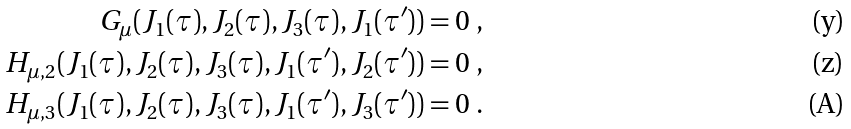<formula> <loc_0><loc_0><loc_500><loc_500>G _ { \mu } ( J _ { 1 } ( \tau ) , J _ { 2 } ( \tau ) , J _ { 3 } ( \tau ) , J _ { 1 } ( \tau ^ { \prime } ) ) = 0 \ , \\ H _ { \mu , 2 } ( J _ { 1 } ( \tau ) , J _ { 2 } ( \tau ) , J _ { 3 } ( \tau ) , J _ { 1 } ( \tau ^ { \prime } ) , J _ { 2 } ( \tau ^ { \prime } ) ) = 0 \ , \\ H _ { \mu , 3 } ( J _ { 1 } ( \tau ) , J _ { 2 } ( \tau ) , J _ { 3 } ( \tau ) , J _ { 1 } ( \tau ^ { \prime } ) , J _ { 3 } ( \tau ^ { \prime } ) ) = 0 \ .</formula> 